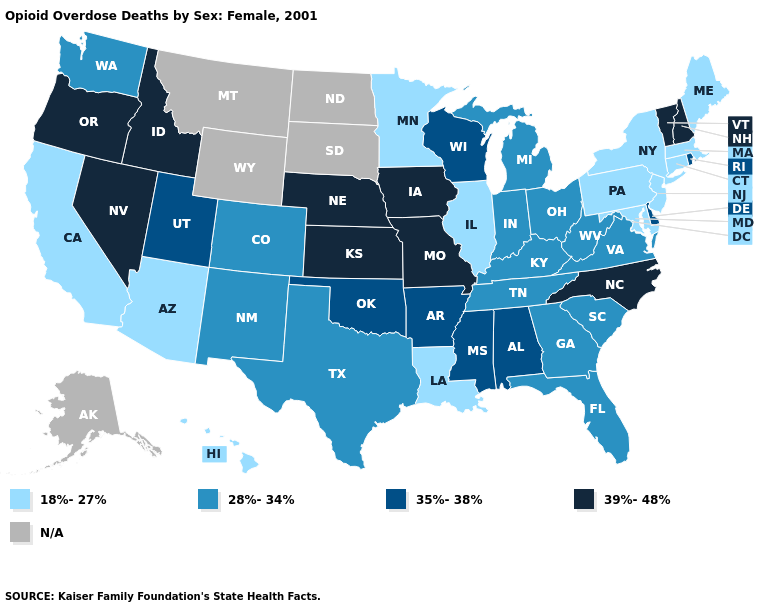Name the states that have a value in the range 18%-27%?
Be succinct. Arizona, California, Connecticut, Hawaii, Illinois, Louisiana, Maine, Maryland, Massachusetts, Minnesota, New Jersey, New York, Pennsylvania. Name the states that have a value in the range 39%-48%?
Give a very brief answer. Idaho, Iowa, Kansas, Missouri, Nebraska, Nevada, New Hampshire, North Carolina, Oregon, Vermont. What is the value of Maryland?
Be succinct. 18%-27%. Name the states that have a value in the range 18%-27%?
Quick response, please. Arizona, California, Connecticut, Hawaii, Illinois, Louisiana, Maine, Maryland, Massachusetts, Minnesota, New Jersey, New York, Pennsylvania. What is the lowest value in the USA?
Be succinct. 18%-27%. Name the states that have a value in the range 28%-34%?
Write a very short answer. Colorado, Florida, Georgia, Indiana, Kentucky, Michigan, New Mexico, Ohio, South Carolina, Tennessee, Texas, Virginia, Washington, West Virginia. Does the first symbol in the legend represent the smallest category?
Keep it brief. Yes. What is the value of Arizona?
Write a very short answer. 18%-27%. How many symbols are there in the legend?
Answer briefly. 5. What is the value of Tennessee?
Write a very short answer. 28%-34%. Does Maine have the highest value in the Northeast?
Concise answer only. No. Does New Mexico have the lowest value in the USA?
Concise answer only. No. What is the value of Nevada?
Concise answer only. 39%-48%. What is the value of Alabama?
Short answer required. 35%-38%. Which states have the highest value in the USA?
Concise answer only. Idaho, Iowa, Kansas, Missouri, Nebraska, Nevada, New Hampshire, North Carolina, Oregon, Vermont. 